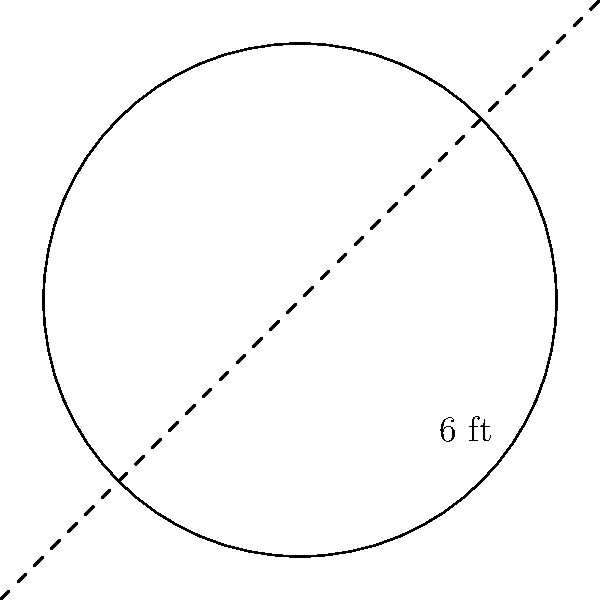In the children's section of your library, you're designing a circular reading nook with a decorative rug. The rug has a diameter of 6 feet. Calculate the area of the rug to determine how much space it will cover in square feet. Round your answer to two decimal places. To find the area of the circular rug, we'll follow these steps:

1. Identify the formula for the area of a circle:
   $A = \pi r^2$, where $A$ is the area and $r$ is the radius.

2. Determine the radius:
   The diameter is given as 6 feet.
   Radius = Diameter ÷ 2
   $r = 6 \div 2 = 3$ feet

3. Substitute the radius into the formula:
   $A = \pi (3)^2$

4. Calculate:
   $A = \pi \cdot 9 \approx 28.27433$ square feet

5. Round to two decimal places:
   $A \approx 28.27$ square feet

This area represents the space the circular rug will cover in the children's reading nook.
Answer: 28.27 sq ft 